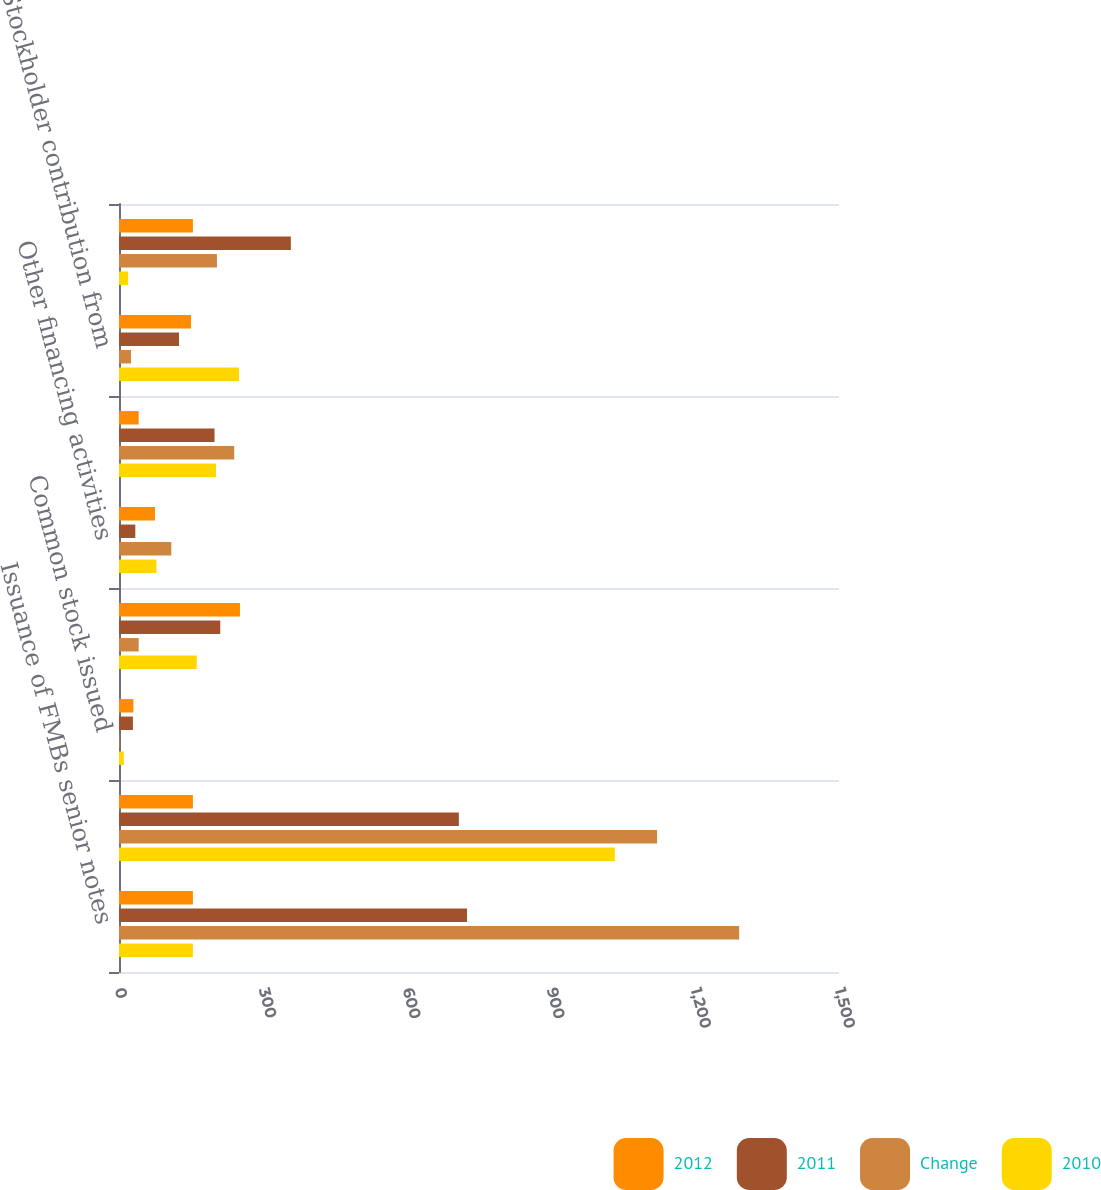Convert chart to OTSL. <chart><loc_0><loc_0><loc_500><loc_500><stacked_bar_chart><ecel><fcel>Issuance of FMBs senior notes<fcel>Retirement of debt<fcel>Common stock issued<fcel>Payments of common and<fcel>Other financing activities<fcel>Net cash provided by (used in)<fcel>Stockholder contribution from<fcel>Net cash used in financing<nl><fcel>2012<fcel>154<fcel>154<fcel>30<fcel>252<fcel>75<fcel>41<fcel>150<fcel>154<nl><fcel>2011<fcel>725<fcel>708<fcel>29<fcel>211<fcel>34<fcel>199<fcel>125<fcel>358<nl><fcel>Change<fcel>1292<fcel>1121<fcel>1<fcel>41<fcel>109<fcel>240<fcel>25<fcel>204<nl><fcel>2010<fcel>154<fcel>1033<fcel>10<fcel>162<fcel>78<fcel>202<fcel>250<fcel>19<nl></chart> 